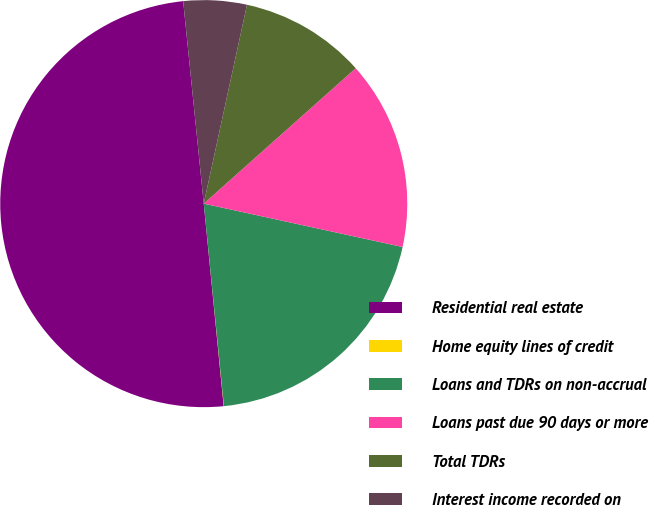Convert chart to OTSL. <chart><loc_0><loc_0><loc_500><loc_500><pie_chart><fcel>Residential real estate<fcel>Home equity lines of credit<fcel>Loans and TDRs on non-accrual<fcel>Loans past due 90 days or more<fcel>Total TDRs<fcel>Interest income recorded on<nl><fcel>49.95%<fcel>0.02%<fcel>20.0%<fcel>15.0%<fcel>10.01%<fcel>5.02%<nl></chart> 